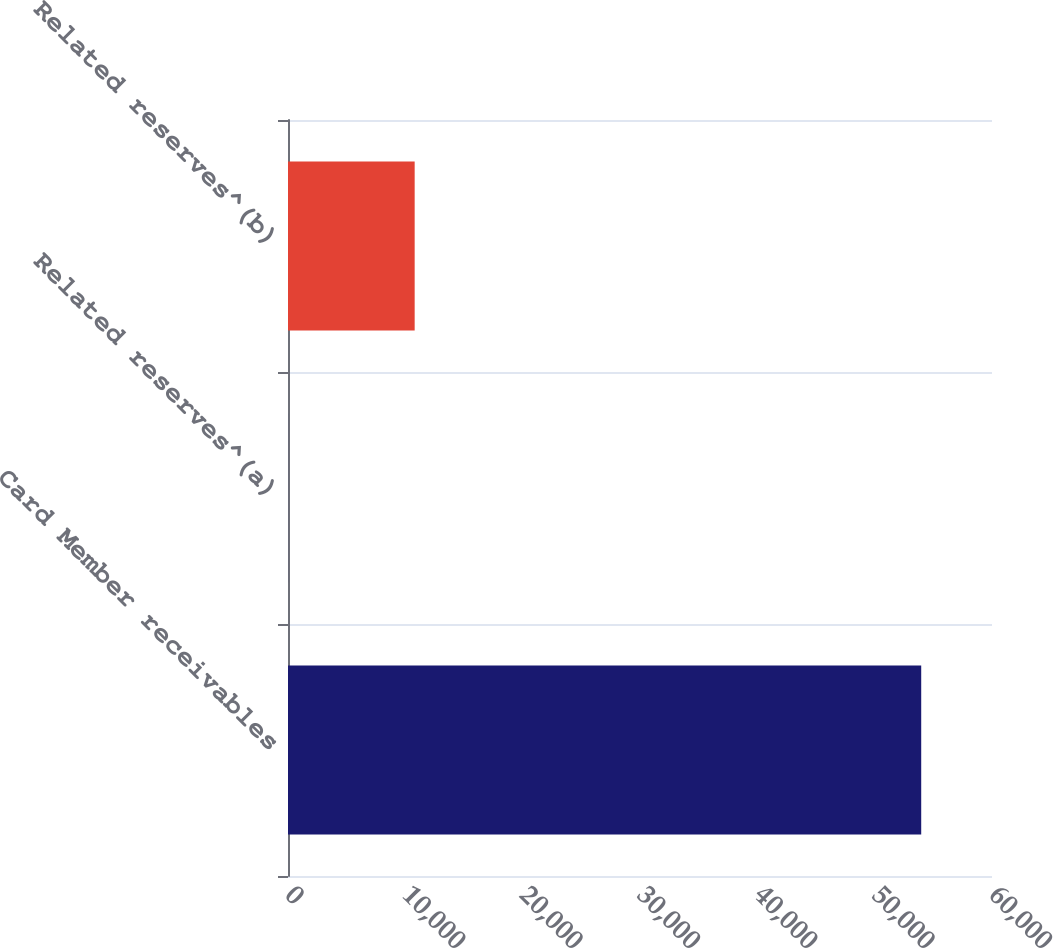Convert chart. <chart><loc_0><loc_0><loc_500><loc_500><bar_chart><fcel>Card Member receivables<fcel>Related reserves^(a)<fcel>Related reserves^(b)<nl><fcel>53967<fcel>3<fcel>10795.8<nl></chart> 